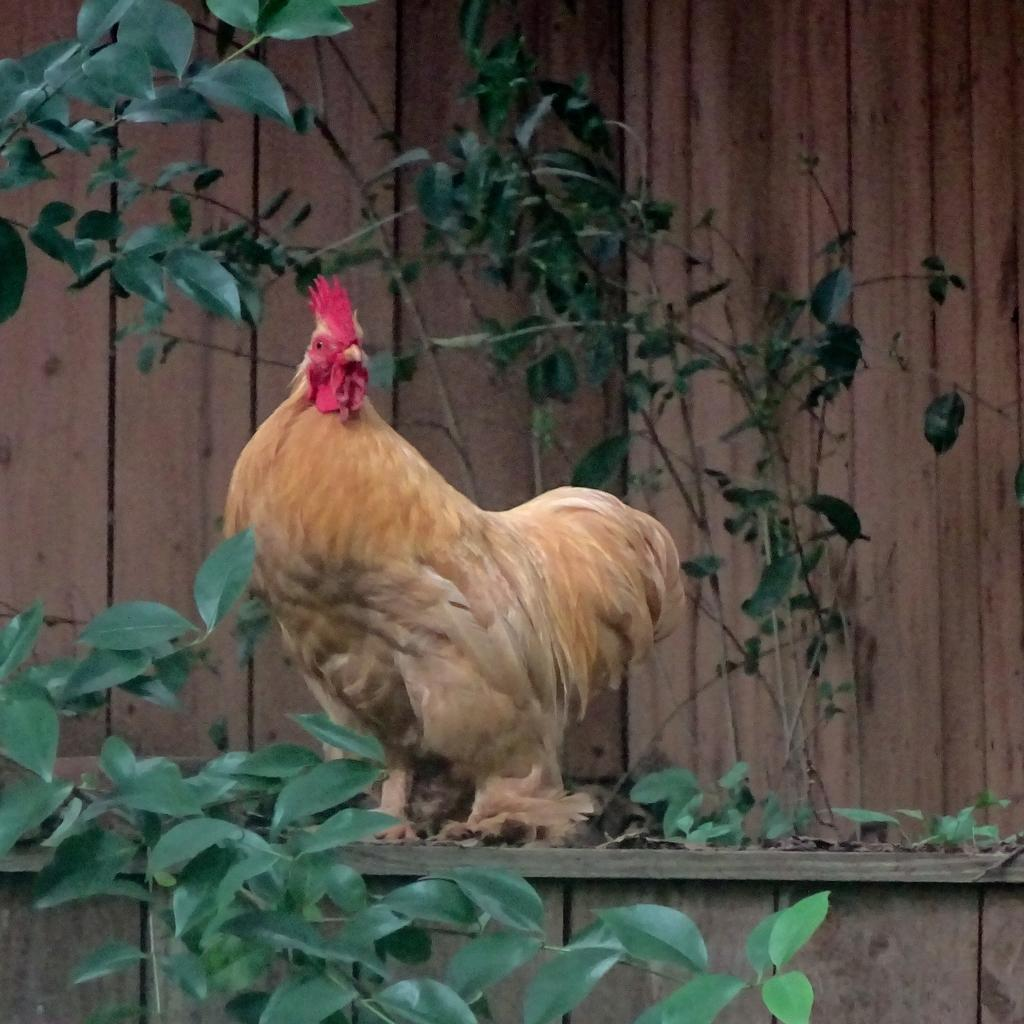What type of animal is present in the image? There is a hen in the image. What is the color of the hen? The hen is brown in color. What else can be seen in the image besides the hen? There are plants in the image. What is visible in the background of the image? There is a wooden wall in the background of the image. What type of kettle is used for religious ceremonies in the image? There is no kettle or religious ceremony present in the image; it features a brown hen and plants. 